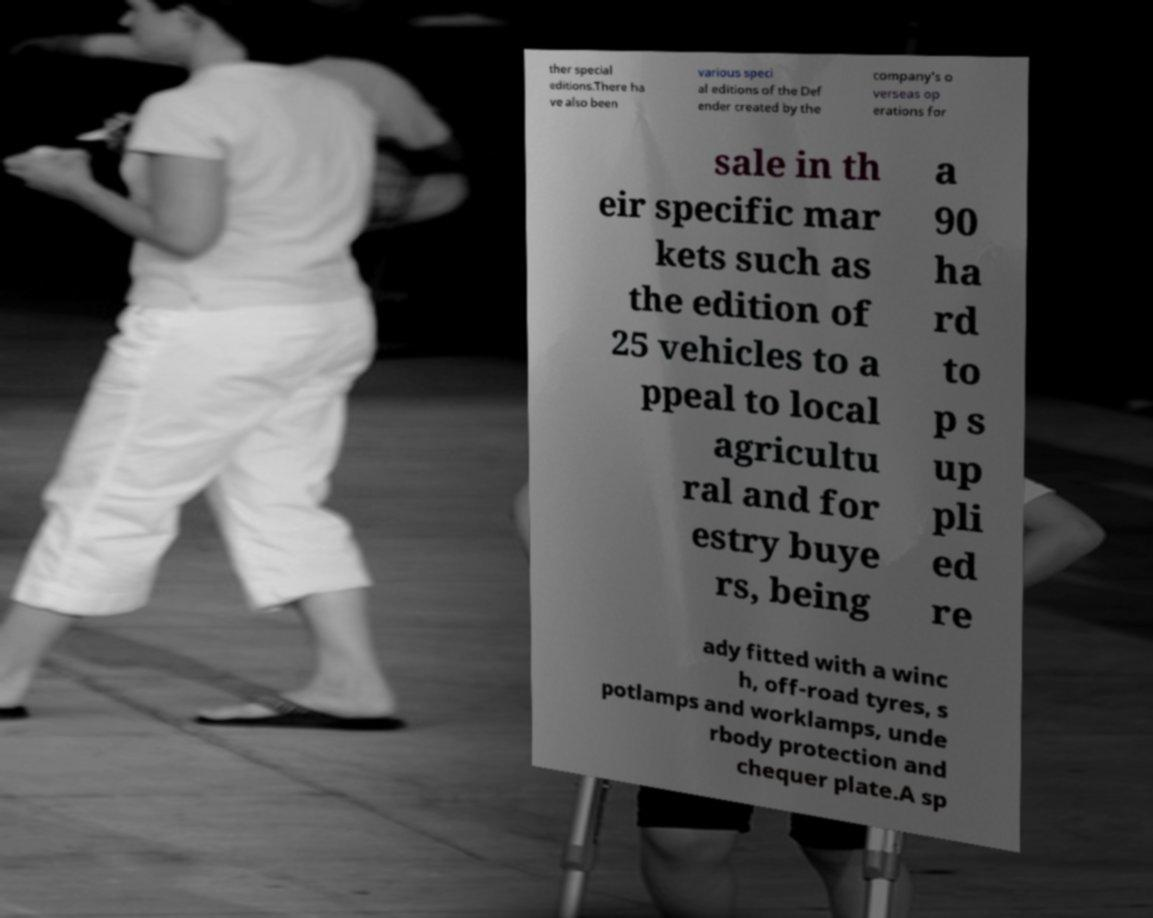Can you read and provide the text displayed in the image?This photo seems to have some interesting text. Can you extract and type it out for me? ther special editions.There ha ve also been various speci al editions of the Def ender created by the company's o verseas op erations for sale in th eir specific mar kets such as the edition of 25 vehicles to a ppeal to local agricultu ral and for estry buye rs, being a 90 ha rd to p s up pli ed re ady fitted with a winc h, off-road tyres, s potlamps and worklamps, unde rbody protection and chequer plate.A sp 